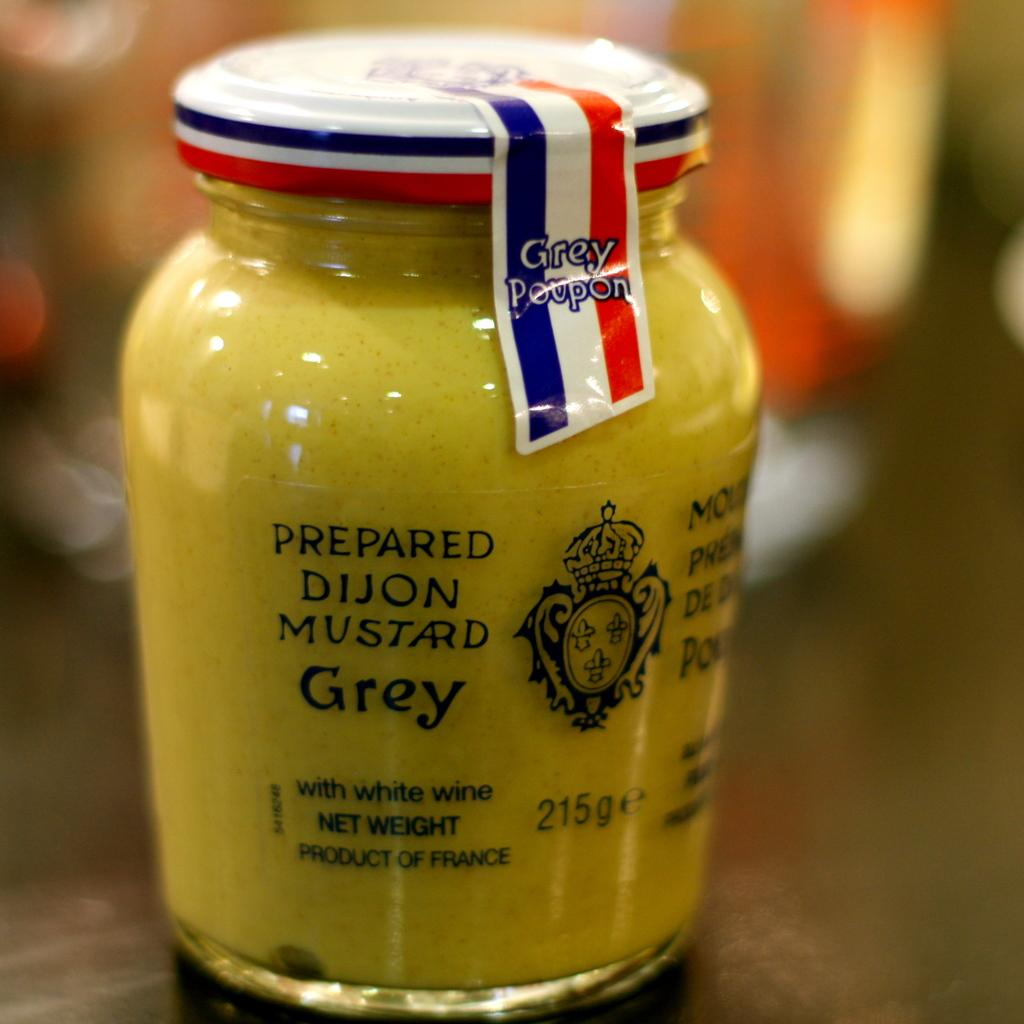<image>
Present a compact description of the photo's key features. A sealed jar of Prepared Dijon Mustard Grey Poupon. 